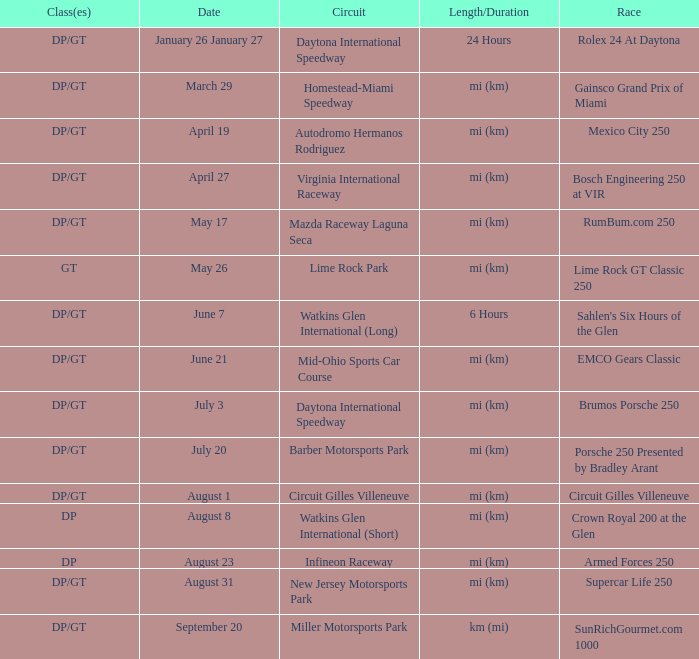What was the date of the race that lasted 6 hours? June 7. 